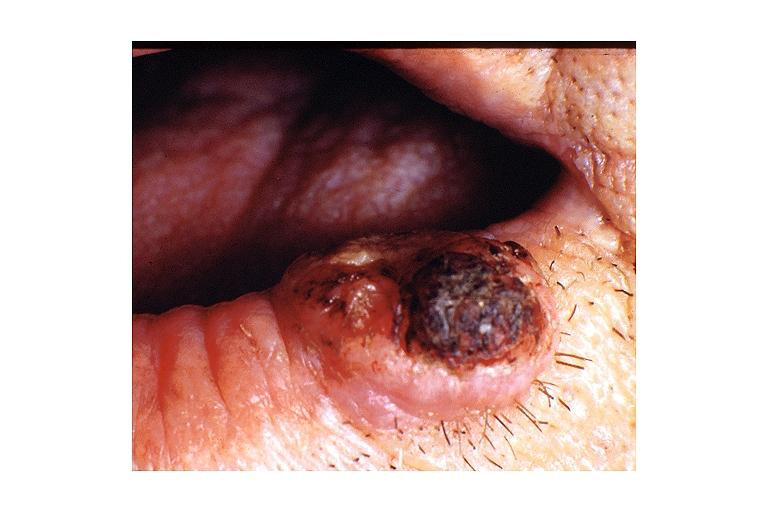what does this image show?
Answer the question using a single word or phrase. Keratoacanthoma 